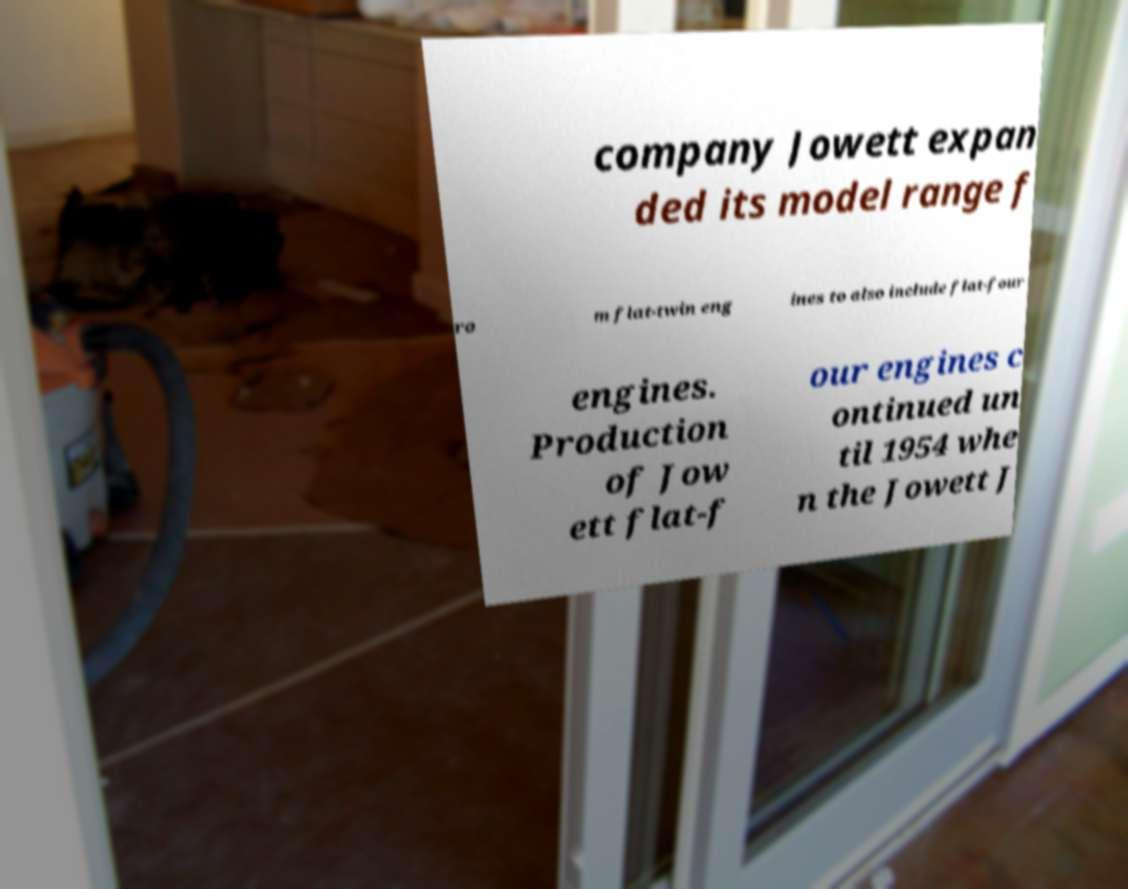Please identify and transcribe the text found in this image. company Jowett expan ded its model range f ro m flat-twin eng ines to also include flat-four engines. Production of Jow ett flat-f our engines c ontinued un til 1954 whe n the Jowett J 